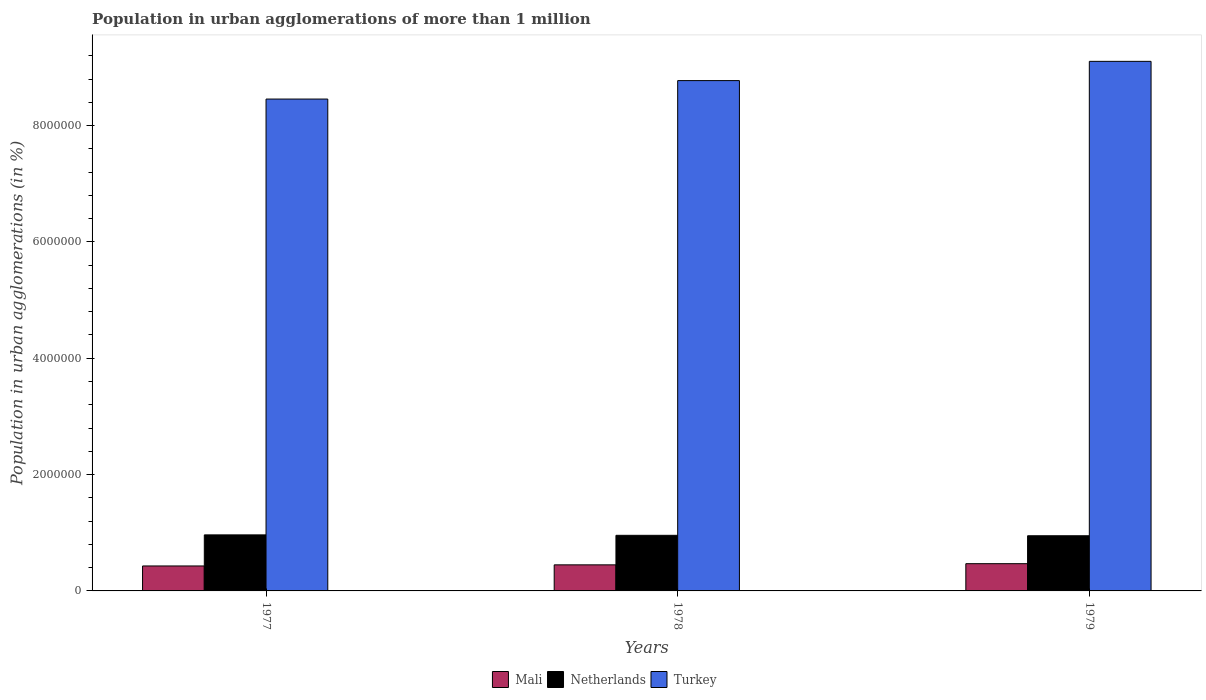How many different coloured bars are there?
Offer a very short reply. 3. How many bars are there on the 3rd tick from the left?
Offer a terse response. 3. What is the label of the 3rd group of bars from the left?
Provide a succinct answer. 1979. In how many cases, is the number of bars for a given year not equal to the number of legend labels?
Give a very brief answer. 0. What is the population in urban agglomerations in Netherlands in 1978?
Provide a succinct answer. 9.56e+05. Across all years, what is the maximum population in urban agglomerations in Turkey?
Offer a very short reply. 9.10e+06. Across all years, what is the minimum population in urban agglomerations in Netherlands?
Make the answer very short. 9.48e+05. In which year was the population in urban agglomerations in Mali maximum?
Offer a terse response. 1979. What is the total population in urban agglomerations in Mali in the graph?
Provide a succinct answer. 1.35e+06. What is the difference between the population in urban agglomerations in Mali in 1977 and that in 1979?
Offer a very short reply. -3.90e+04. What is the difference between the population in urban agglomerations in Netherlands in 1978 and the population in urban agglomerations in Mali in 1979?
Your answer should be compact. 4.88e+05. What is the average population in urban agglomerations in Turkey per year?
Offer a terse response. 8.78e+06. In the year 1978, what is the difference between the population in urban agglomerations in Mali and population in urban agglomerations in Turkey?
Keep it short and to the point. -8.32e+06. In how many years, is the population in urban agglomerations in Mali greater than 8800000 %?
Offer a very short reply. 0. What is the ratio of the population in urban agglomerations in Turkey in 1977 to that in 1979?
Give a very brief answer. 0.93. What is the difference between the highest and the second highest population in urban agglomerations in Netherlands?
Your answer should be very brief. 7484. What is the difference between the highest and the lowest population in urban agglomerations in Mali?
Your response must be concise. 3.90e+04. In how many years, is the population in urban agglomerations in Turkey greater than the average population in urban agglomerations in Turkey taken over all years?
Keep it short and to the point. 1. What does the 3rd bar from the right in 1978 represents?
Give a very brief answer. Mali. How many bars are there?
Ensure brevity in your answer.  9. How many years are there in the graph?
Make the answer very short. 3. Are the values on the major ticks of Y-axis written in scientific E-notation?
Offer a terse response. No. What is the title of the graph?
Your response must be concise. Population in urban agglomerations of more than 1 million. Does "North America" appear as one of the legend labels in the graph?
Make the answer very short. No. What is the label or title of the Y-axis?
Provide a short and direct response. Population in urban agglomerations (in %). What is the Population in urban agglomerations (in %) of Mali in 1977?
Offer a very short reply. 4.29e+05. What is the Population in urban agglomerations (in %) of Netherlands in 1977?
Provide a succinct answer. 9.63e+05. What is the Population in urban agglomerations (in %) in Turkey in 1977?
Offer a very short reply. 8.46e+06. What is the Population in urban agglomerations (in %) of Mali in 1978?
Ensure brevity in your answer.  4.48e+05. What is the Population in urban agglomerations (in %) of Netherlands in 1978?
Offer a very short reply. 9.56e+05. What is the Population in urban agglomerations (in %) of Turkey in 1978?
Keep it short and to the point. 8.77e+06. What is the Population in urban agglomerations (in %) of Mali in 1979?
Your response must be concise. 4.68e+05. What is the Population in urban agglomerations (in %) in Netherlands in 1979?
Your answer should be very brief. 9.48e+05. What is the Population in urban agglomerations (in %) in Turkey in 1979?
Offer a terse response. 9.10e+06. Across all years, what is the maximum Population in urban agglomerations (in %) of Mali?
Your response must be concise. 4.68e+05. Across all years, what is the maximum Population in urban agglomerations (in %) of Netherlands?
Provide a succinct answer. 9.63e+05. Across all years, what is the maximum Population in urban agglomerations (in %) of Turkey?
Ensure brevity in your answer.  9.10e+06. Across all years, what is the minimum Population in urban agglomerations (in %) in Mali?
Offer a very short reply. 4.29e+05. Across all years, what is the minimum Population in urban agglomerations (in %) of Netherlands?
Ensure brevity in your answer.  9.48e+05. Across all years, what is the minimum Population in urban agglomerations (in %) of Turkey?
Ensure brevity in your answer.  8.46e+06. What is the total Population in urban agglomerations (in %) of Mali in the graph?
Ensure brevity in your answer.  1.35e+06. What is the total Population in urban agglomerations (in %) of Netherlands in the graph?
Offer a terse response. 2.87e+06. What is the total Population in urban agglomerations (in %) of Turkey in the graph?
Ensure brevity in your answer.  2.63e+07. What is the difference between the Population in urban agglomerations (in %) in Mali in 1977 and that in 1978?
Provide a succinct answer. -1.91e+04. What is the difference between the Population in urban agglomerations (in %) in Netherlands in 1977 and that in 1978?
Your answer should be compact. 7484. What is the difference between the Population in urban agglomerations (in %) of Turkey in 1977 and that in 1978?
Your answer should be very brief. -3.17e+05. What is the difference between the Population in urban agglomerations (in %) in Mali in 1977 and that in 1979?
Provide a succinct answer. -3.90e+04. What is the difference between the Population in urban agglomerations (in %) of Netherlands in 1977 and that in 1979?
Your answer should be very brief. 1.49e+04. What is the difference between the Population in urban agglomerations (in %) in Turkey in 1977 and that in 1979?
Your answer should be compact. -6.48e+05. What is the difference between the Population in urban agglomerations (in %) in Mali in 1978 and that in 1979?
Ensure brevity in your answer.  -1.99e+04. What is the difference between the Population in urban agglomerations (in %) in Netherlands in 1978 and that in 1979?
Offer a terse response. 7426. What is the difference between the Population in urban agglomerations (in %) in Turkey in 1978 and that in 1979?
Make the answer very short. -3.31e+05. What is the difference between the Population in urban agglomerations (in %) of Mali in 1977 and the Population in urban agglomerations (in %) of Netherlands in 1978?
Your answer should be compact. -5.27e+05. What is the difference between the Population in urban agglomerations (in %) in Mali in 1977 and the Population in urban agglomerations (in %) in Turkey in 1978?
Keep it short and to the point. -8.34e+06. What is the difference between the Population in urban agglomerations (in %) in Netherlands in 1977 and the Population in urban agglomerations (in %) in Turkey in 1978?
Your answer should be very brief. -7.81e+06. What is the difference between the Population in urban agglomerations (in %) of Mali in 1977 and the Population in urban agglomerations (in %) of Netherlands in 1979?
Provide a succinct answer. -5.19e+05. What is the difference between the Population in urban agglomerations (in %) in Mali in 1977 and the Population in urban agglomerations (in %) in Turkey in 1979?
Make the answer very short. -8.67e+06. What is the difference between the Population in urban agglomerations (in %) in Netherlands in 1977 and the Population in urban agglomerations (in %) in Turkey in 1979?
Your answer should be very brief. -8.14e+06. What is the difference between the Population in urban agglomerations (in %) of Mali in 1978 and the Population in urban agglomerations (in %) of Netherlands in 1979?
Keep it short and to the point. -5.00e+05. What is the difference between the Population in urban agglomerations (in %) in Mali in 1978 and the Population in urban agglomerations (in %) in Turkey in 1979?
Make the answer very short. -8.66e+06. What is the difference between the Population in urban agglomerations (in %) in Netherlands in 1978 and the Population in urban agglomerations (in %) in Turkey in 1979?
Make the answer very short. -8.15e+06. What is the average Population in urban agglomerations (in %) of Mali per year?
Give a very brief answer. 4.49e+05. What is the average Population in urban agglomerations (in %) of Netherlands per year?
Ensure brevity in your answer.  9.56e+05. What is the average Population in urban agglomerations (in %) in Turkey per year?
Your answer should be compact. 8.78e+06. In the year 1977, what is the difference between the Population in urban agglomerations (in %) in Mali and Population in urban agglomerations (in %) in Netherlands?
Your answer should be compact. -5.34e+05. In the year 1977, what is the difference between the Population in urban agglomerations (in %) of Mali and Population in urban agglomerations (in %) of Turkey?
Offer a very short reply. -8.03e+06. In the year 1977, what is the difference between the Population in urban agglomerations (in %) in Netherlands and Population in urban agglomerations (in %) in Turkey?
Keep it short and to the point. -7.49e+06. In the year 1978, what is the difference between the Population in urban agglomerations (in %) of Mali and Population in urban agglomerations (in %) of Netherlands?
Provide a succinct answer. -5.08e+05. In the year 1978, what is the difference between the Population in urban agglomerations (in %) of Mali and Population in urban agglomerations (in %) of Turkey?
Your answer should be very brief. -8.32e+06. In the year 1978, what is the difference between the Population in urban agglomerations (in %) in Netherlands and Population in urban agglomerations (in %) in Turkey?
Your response must be concise. -7.82e+06. In the year 1979, what is the difference between the Population in urban agglomerations (in %) in Mali and Population in urban agglomerations (in %) in Netherlands?
Ensure brevity in your answer.  -4.80e+05. In the year 1979, what is the difference between the Population in urban agglomerations (in %) in Mali and Population in urban agglomerations (in %) in Turkey?
Give a very brief answer. -8.64e+06. In the year 1979, what is the difference between the Population in urban agglomerations (in %) in Netherlands and Population in urban agglomerations (in %) in Turkey?
Give a very brief answer. -8.16e+06. What is the ratio of the Population in urban agglomerations (in %) of Mali in 1977 to that in 1978?
Make the answer very short. 0.96. What is the ratio of the Population in urban agglomerations (in %) of Netherlands in 1977 to that in 1978?
Ensure brevity in your answer.  1.01. What is the ratio of the Population in urban agglomerations (in %) in Turkey in 1977 to that in 1978?
Ensure brevity in your answer.  0.96. What is the ratio of the Population in urban agglomerations (in %) in Mali in 1977 to that in 1979?
Your answer should be very brief. 0.92. What is the ratio of the Population in urban agglomerations (in %) in Netherlands in 1977 to that in 1979?
Your answer should be compact. 1.02. What is the ratio of the Population in urban agglomerations (in %) of Turkey in 1977 to that in 1979?
Offer a very short reply. 0.93. What is the ratio of the Population in urban agglomerations (in %) in Mali in 1978 to that in 1979?
Your response must be concise. 0.96. What is the ratio of the Population in urban agglomerations (in %) of Netherlands in 1978 to that in 1979?
Ensure brevity in your answer.  1.01. What is the ratio of the Population in urban agglomerations (in %) in Turkey in 1978 to that in 1979?
Offer a very short reply. 0.96. What is the difference between the highest and the second highest Population in urban agglomerations (in %) of Mali?
Your response must be concise. 1.99e+04. What is the difference between the highest and the second highest Population in urban agglomerations (in %) of Netherlands?
Your answer should be compact. 7484. What is the difference between the highest and the second highest Population in urban agglomerations (in %) in Turkey?
Your response must be concise. 3.31e+05. What is the difference between the highest and the lowest Population in urban agglomerations (in %) of Mali?
Ensure brevity in your answer.  3.90e+04. What is the difference between the highest and the lowest Population in urban agglomerations (in %) of Netherlands?
Your response must be concise. 1.49e+04. What is the difference between the highest and the lowest Population in urban agglomerations (in %) in Turkey?
Your response must be concise. 6.48e+05. 